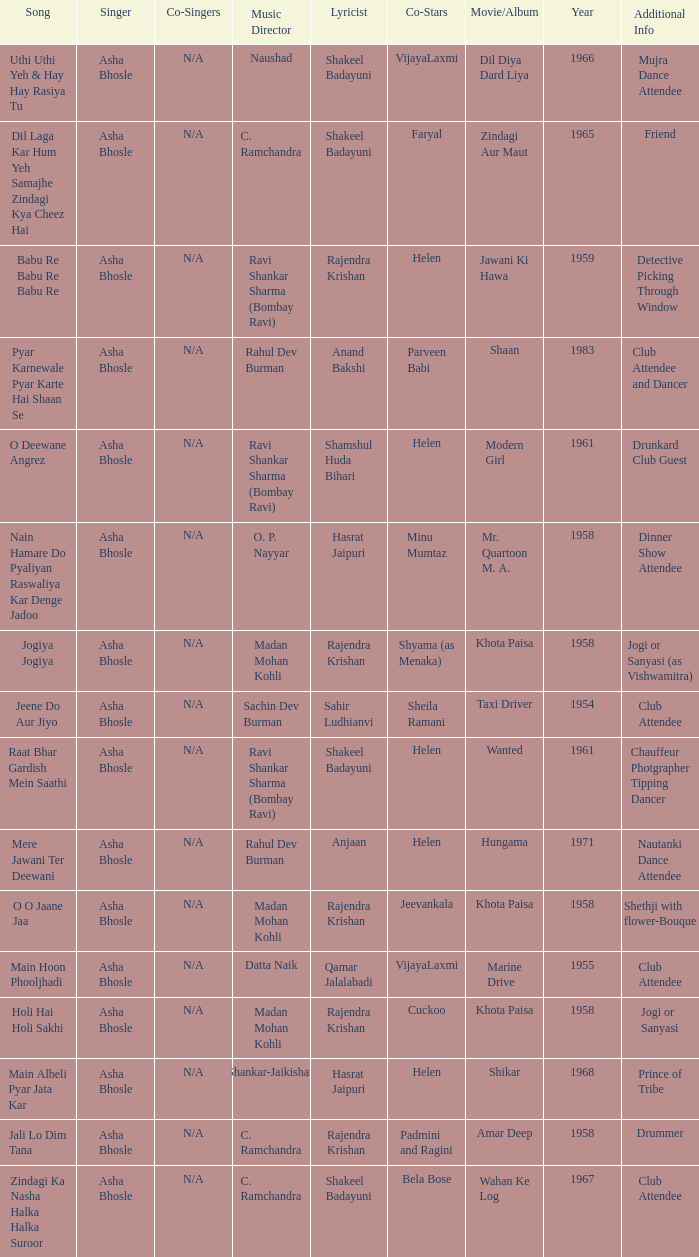What movie did Vijayalaxmi Co-star in and Shakeel Badayuni write the lyrics? Dil Diya Dard Liya. 